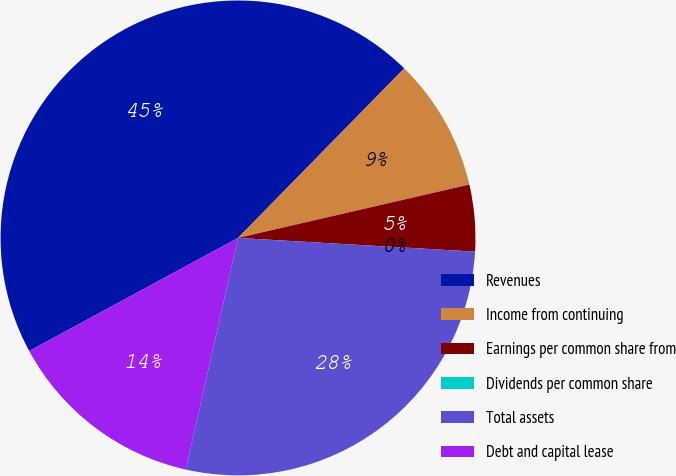Convert chart to OTSL. <chart><loc_0><loc_0><loc_500><loc_500><pie_chart><fcel>Revenues<fcel>Income from continuing<fcel>Earnings per common share from<fcel>Dividends per common share<fcel>Total assets<fcel>Debt and capital lease<nl><fcel>45.24%<fcel>9.05%<fcel>4.53%<fcel>0.0%<fcel>27.61%<fcel>13.57%<nl></chart> 